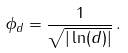Convert formula to latex. <formula><loc_0><loc_0><loc_500><loc_500>\phi _ { d } = \frac { 1 } { \sqrt { | \ln ( d ) | } } \, .</formula> 